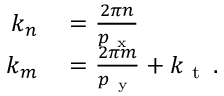Convert formula to latex. <formula><loc_0><loc_0><loc_500><loc_500>\begin{array} { r l } { k _ { n } } & = \frac { 2 \pi n } { p _ { x } } } \\ { k _ { m } } & = \frac { 2 \pi m } { p _ { y } } + k _ { t } \, . } \end{array}</formula> 